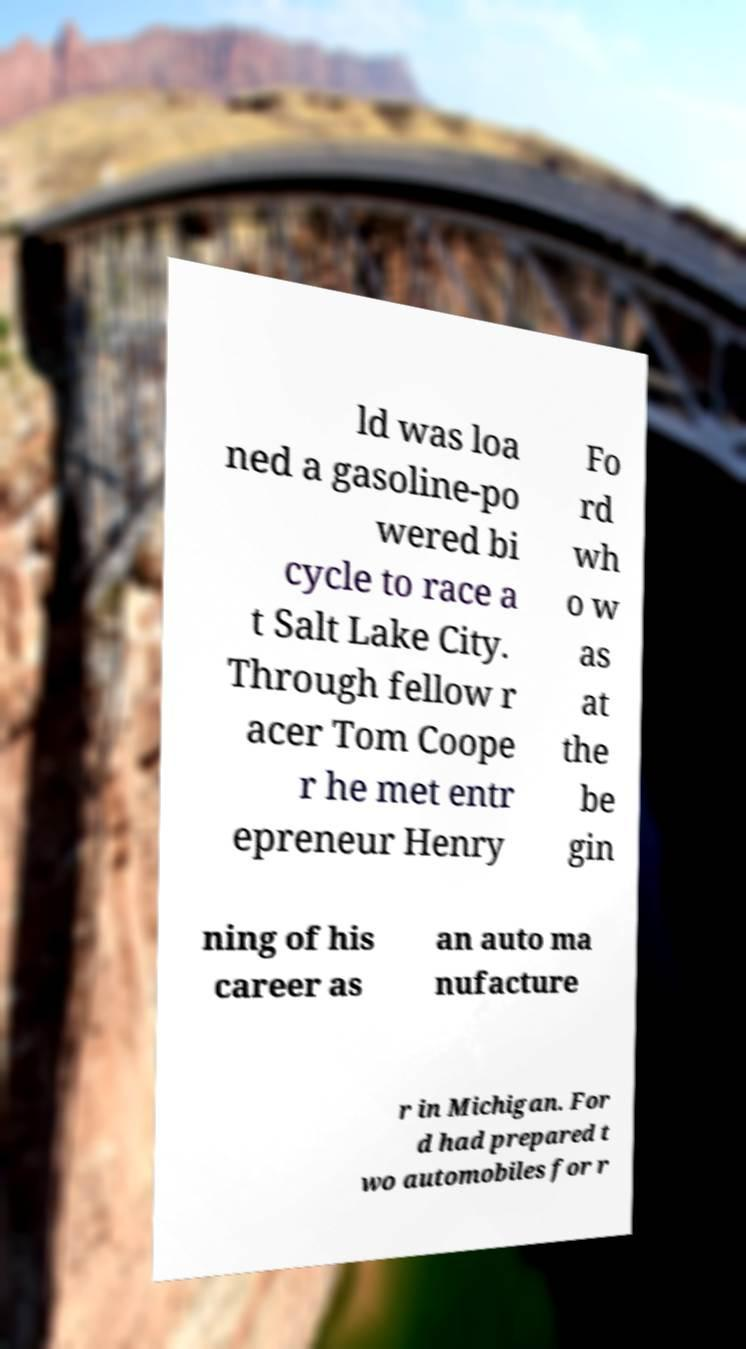Please identify and transcribe the text found in this image. ld was loa ned a gasoline-po wered bi cycle to race a t Salt Lake City. Through fellow r acer Tom Coope r he met entr epreneur Henry Fo rd wh o w as at the be gin ning of his career as an auto ma nufacture r in Michigan. For d had prepared t wo automobiles for r 